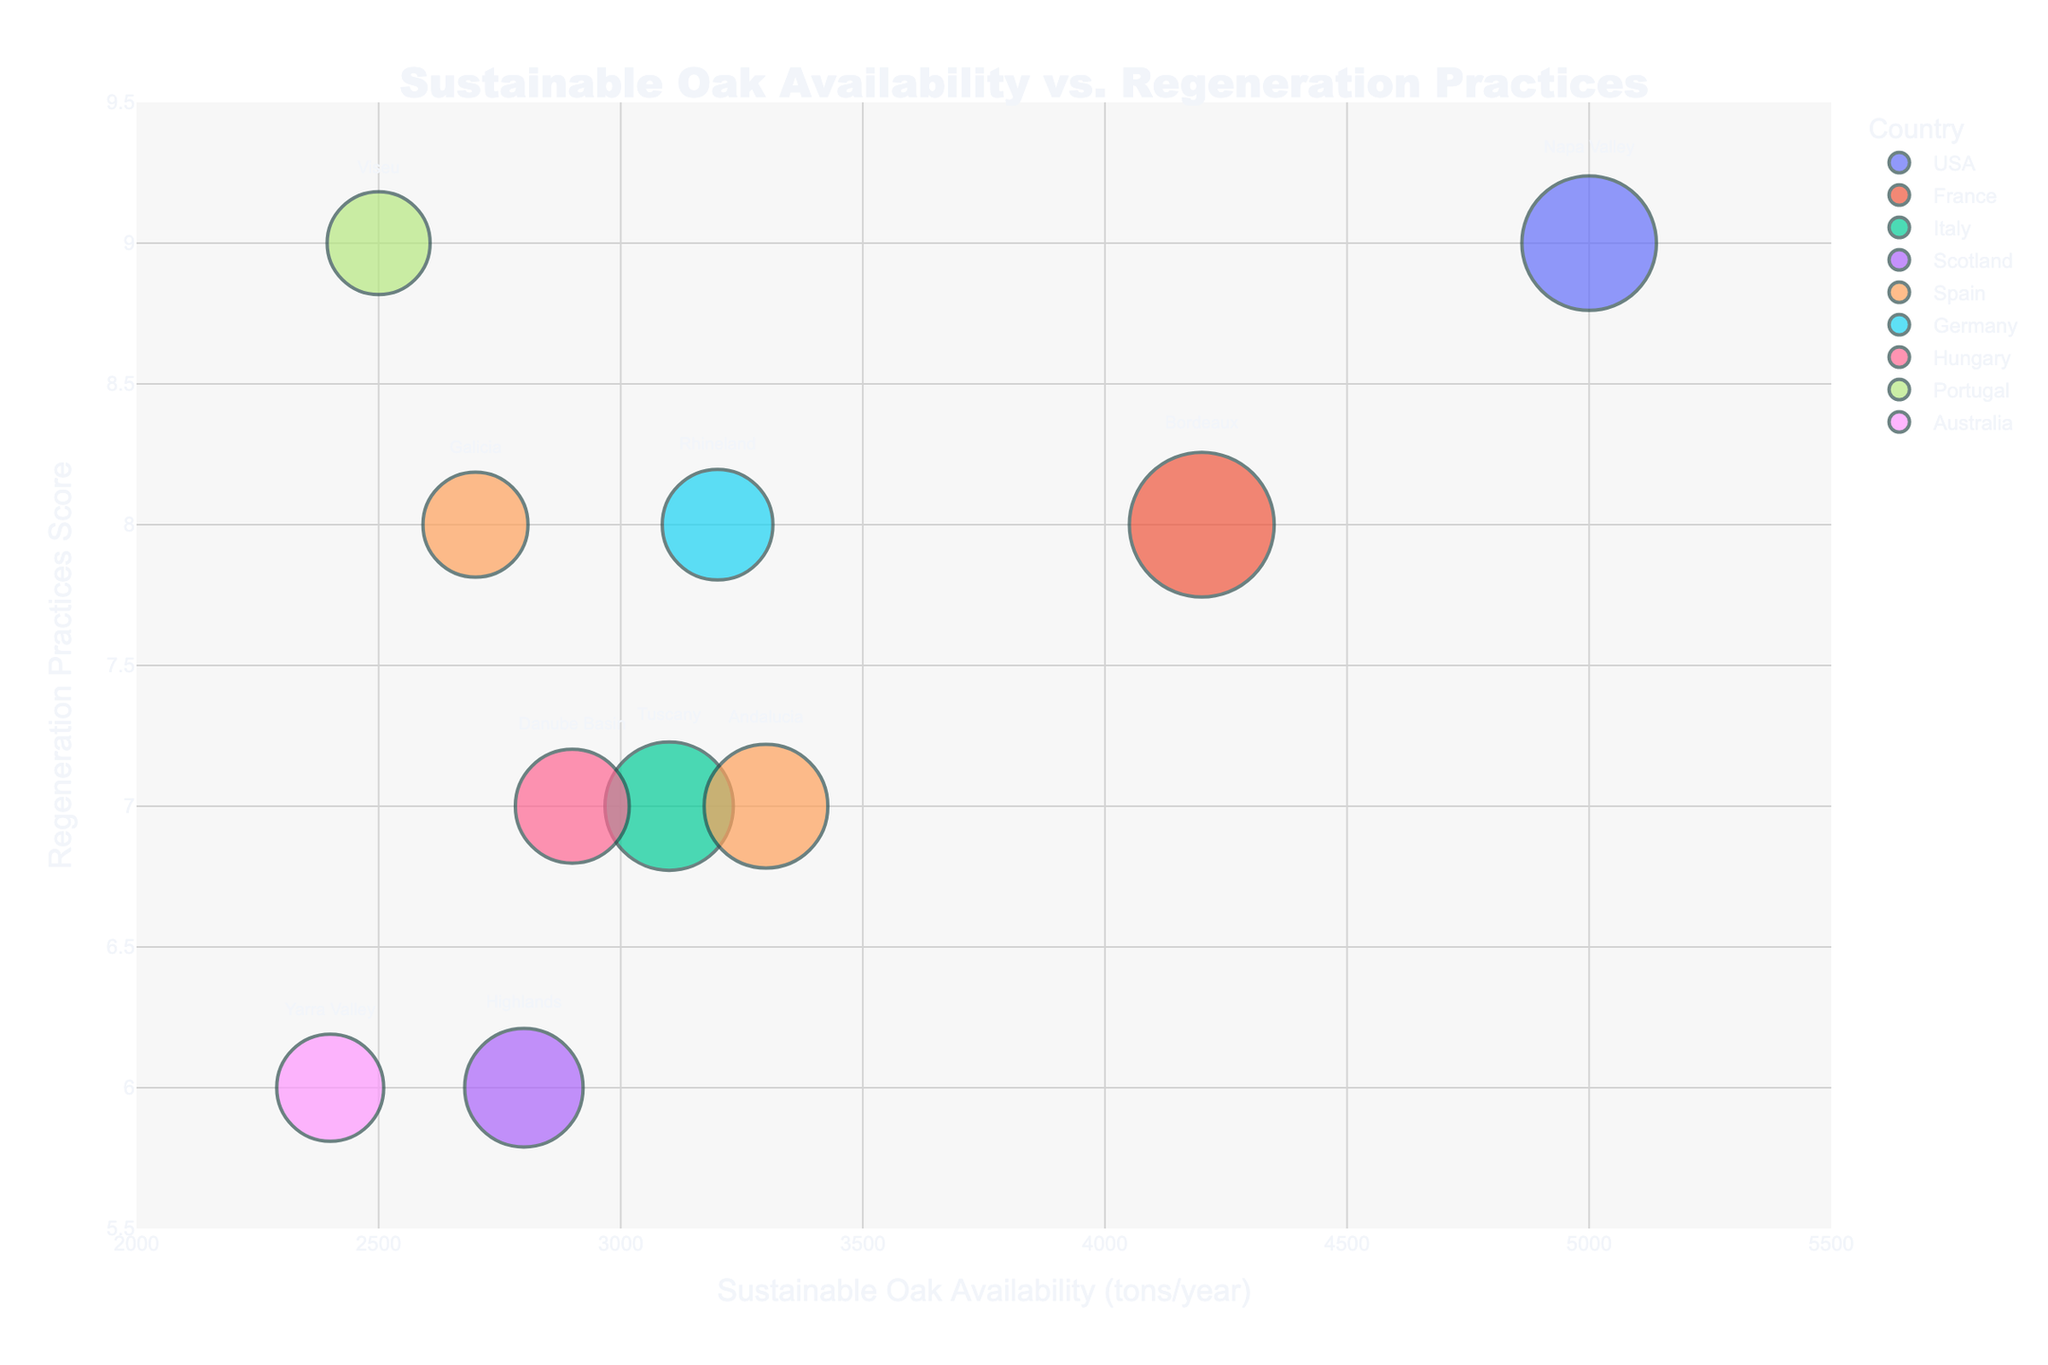**Basic Question:** What is the title of the figure? The title of the figure is located at the top center and is in bold text.
Answer: Sustainable Oak Availability vs. Regeneration Practices **Basic Question:** What is the y-axis title? The y-axis title can be found on the vertical axis of the figure.
Answer: Regeneration Practices Score **Comparison Question:** Which region has the highest Sustainable Oak Availability? By comparing the x-axis positions of all regions, Napa Valley appears furthest to the right, indicating the highest value.
Answer: Napa Valley **Basic Question:** Which region has the highest Regeneration Practices score? By comparing the y-axis positions of all regions, Napa Valley and Viseu are the highest, indicating the maximum score of 9.
Answer: Napa Valley and Viseu **Comparison Question:** Which country has more regions shown in the figure, Spain or Italy? Spain has two regions (Andalucia and Galicia), whereas Italy has one region (Tuscany). Thus, Spain has more regions shown.
Answer: Spain **Compositional Question:** What is the average Regeneration Practices score for regions in Spain? Andalucía has a score of 7, and Galicia has a score of 8. The average is (7 + 8) / 2.
Answer: 7.5 **Basic Question:** How many regions are represented in the figure? Counting all the distinct regions mentioned in the legend indicates there are 10 regions.
Answer: 10 **Comparison Question:** Which regions fall in the range of 3000 to 3500 tons/year for Sustainable Oak Availability? By checking the range on the x-axis, regions that fall within this range include Tuscany and Andalucia.
Answer: Tuscany and Andalucia **Chart-Type Specific Question:** Which region has the smallest bubble size? Bubble size correlates with the smallest forest area, so identifying the smallest bubble visually, corresponds to Viseu.
Answer: Viseu **Compositional Question:** What's the difference in Sustainable Oak Availability between Bordeaux and Highlands? Bordeaux has 4200 tons/year, and Highlands has 2800 tons/year. The difference is 4200 - 2800.
Answer: 1400 